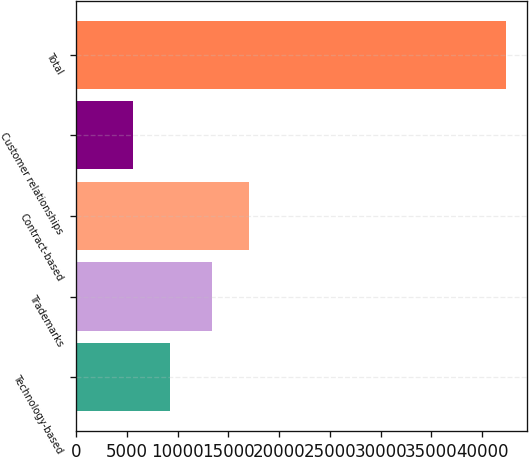Convert chart to OTSL. <chart><loc_0><loc_0><loc_500><loc_500><bar_chart><fcel>Technology-based<fcel>Trademarks<fcel>Contract-based<fcel>Customer relationships<fcel>Total<nl><fcel>9256.8<fcel>13340<fcel>17016.8<fcel>5580<fcel>42348<nl></chart> 